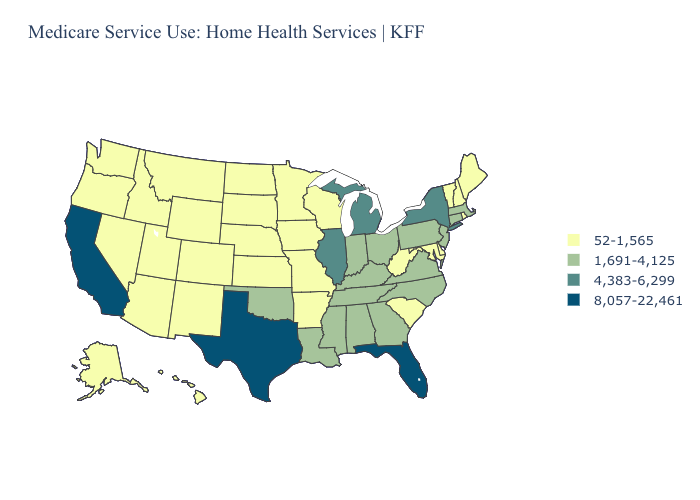What is the value of Oklahoma?
Quick response, please. 1,691-4,125. What is the lowest value in the USA?
Be succinct. 52-1,565. Name the states that have a value in the range 1,691-4,125?
Short answer required. Alabama, Connecticut, Georgia, Indiana, Kentucky, Louisiana, Massachusetts, Mississippi, New Jersey, North Carolina, Ohio, Oklahoma, Pennsylvania, Tennessee, Virginia. What is the lowest value in states that border Iowa?
Be succinct. 52-1,565. Name the states that have a value in the range 52-1,565?
Be succinct. Alaska, Arizona, Arkansas, Colorado, Delaware, Hawaii, Idaho, Iowa, Kansas, Maine, Maryland, Minnesota, Missouri, Montana, Nebraska, Nevada, New Hampshire, New Mexico, North Dakota, Oregon, Rhode Island, South Carolina, South Dakota, Utah, Vermont, Washington, West Virginia, Wisconsin, Wyoming. What is the value of New York?
Concise answer only. 4,383-6,299. What is the lowest value in the MidWest?
Write a very short answer. 52-1,565. Does Colorado have the same value as Montana?
Give a very brief answer. Yes. Does Washington have the lowest value in the USA?
Be succinct. Yes. Name the states that have a value in the range 52-1,565?
Quick response, please. Alaska, Arizona, Arkansas, Colorado, Delaware, Hawaii, Idaho, Iowa, Kansas, Maine, Maryland, Minnesota, Missouri, Montana, Nebraska, Nevada, New Hampshire, New Mexico, North Dakota, Oregon, Rhode Island, South Carolina, South Dakota, Utah, Vermont, Washington, West Virginia, Wisconsin, Wyoming. How many symbols are there in the legend?
Answer briefly. 4. Does South Dakota have the same value as North Carolina?
Quick response, please. No. Does the first symbol in the legend represent the smallest category?
Keep it brief. Yes. What is the value of Massachusetts?
Answer briefly. 1,691-4,125. Name the states that have a value in the range 4,383-6,299?
Keep it brief. Illinois, Michigan, New York. 